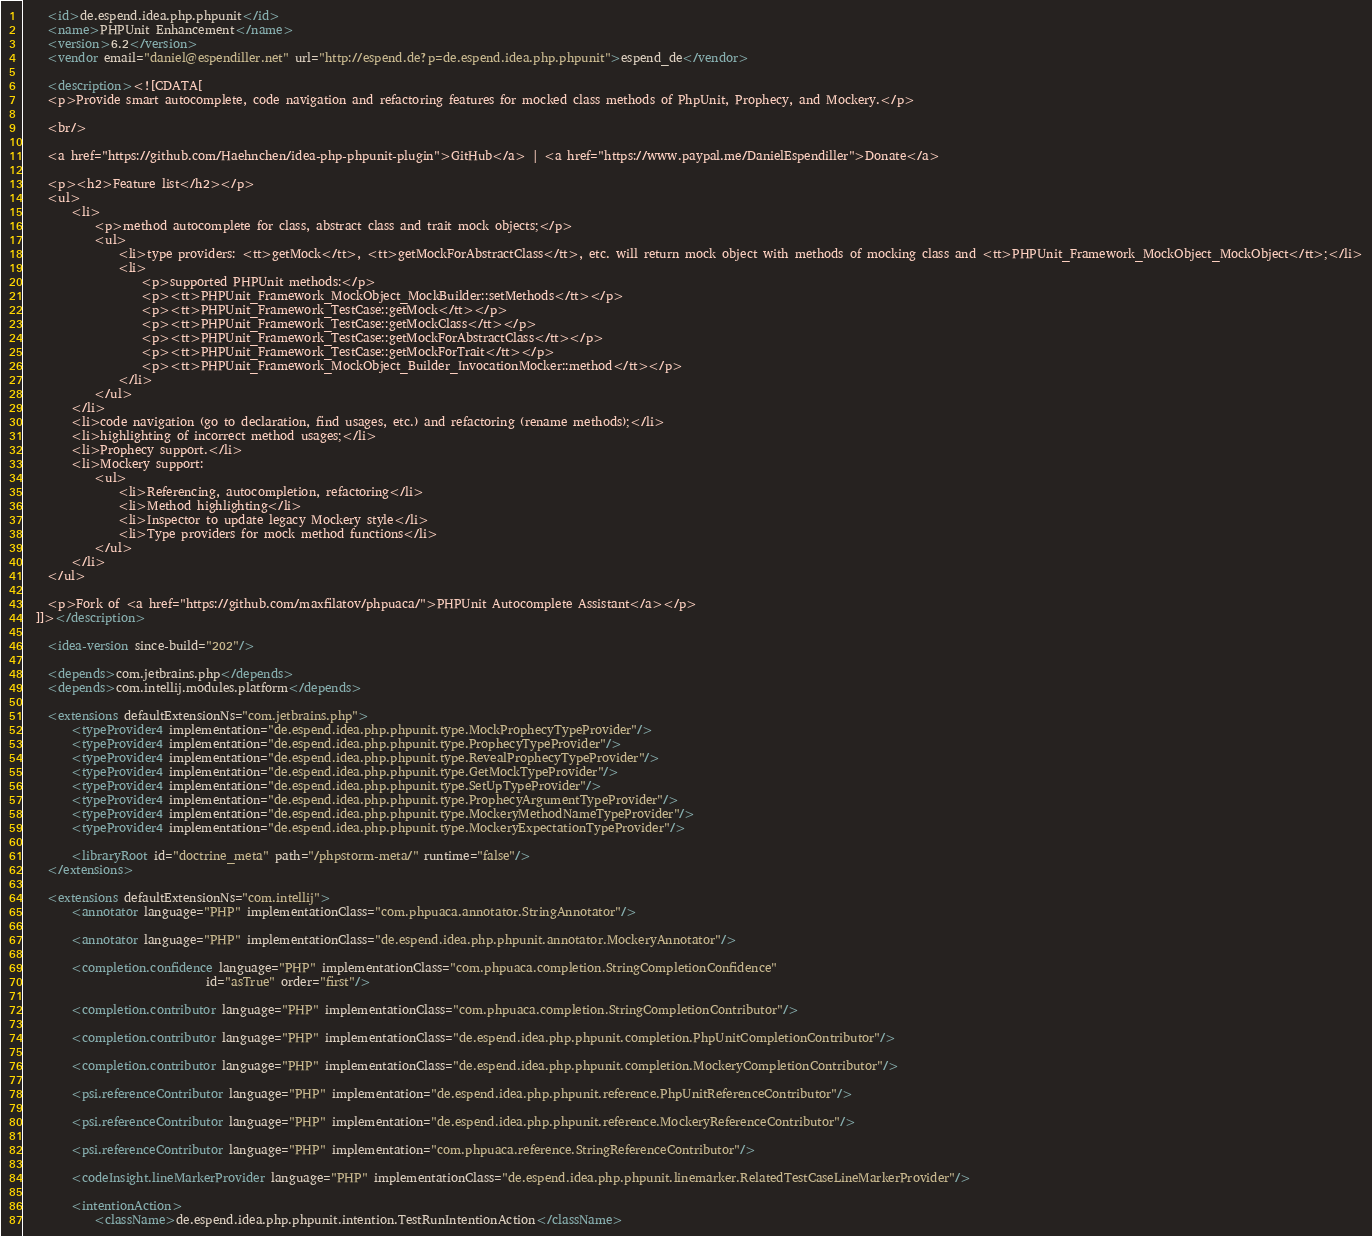<code> <loc_0><loc_0><loc_500><loc_500><_XML_>    <id>de.espend.idea.php.phpunit</id>
    <name>PHPUnit Enhancement</name>
    <version>6.2</version>
    <vendor email="daniel@espendiller.net" url="http://espend.de?p=de.espend.idea.php.phpunit">espend_de</vendor>

    <description><![CDATA[
    <p>Provide smart autocomplete, code navigation and refactoring features for mocked class methods of PhpUnit, Prophecy, and Mockery.</p>

    <br/>

    <a href="https://github.com/Haehnchen/idea-php-phpunit-plugin">GitHub</a> | <a href="https://www.paypal.me/DanielEspendiller">Donate</a>

    <p><h2>Feature list</h2></p>
    <ul>
        <li>
            <p>method autocomplete for class, abstract class and trait mock objects;</p>
            <ul>
                <li>type providers: <tt>getMock</tt>, <tt>getMockForAbstractClass</tt>, etc. will return mock object with methods of mocking class and <tt>PHPUnit_Framework_MockObject_MockObject</tt>;</li>
                <li>
                    <p>supported PHPUnit methods:</p>
                    <p><tt>PHPUnit_Framework_MockObject_MockBuilder::setMethods</tt></p>
                    <p><tt>PHPUnit_Framework_TestCase::getMock</tt></p>
                    <p><tt>PHPUnit_Framework_TestCase::getMockClass</tt></p>
                    <p><tt>PHPUnit_Framework_TestCase::getMockForAbstractClass</tt></p>
                    <p><tt>PHPUnit_Framework_TestCase::getMockForTrait</tt></p>
                    <p><tt>PHPUnit_Framework_MockObject_Builder_InvocationMocker::method</tt></p>
                </li>
            </ul>
        </li>
        <li>code navigation (go to declaration, find usages, etc.) and refactoring (rename methods);</li>
        <li>highlighting of incorrect method usages;</li>
        <li>Prophecy support.</li>
        <li>Mockery support:
            <ul>
                <li>Referencing, autocompletion, refactoring</li>
                <li>Method highlighting</li>
                <li>Inspector to update legacy Mockery style</li>
                <li>Type providers for mock method functions</li>
            </ul>
        </li>
    </ul>

    <p>Fork of <a href="https://github.com/maxfilatov/phpuaca/">PHPUnit Autocomplete Assistant</a></p>
  ]]></description>

    <idea-version since-build="202"/>

    <depends>com.jetbrains.php</depends>
    <depends>com.intellij.modules.platform</depends>

    <extensions defaultExtensionNs="com.jetbrains.php">
        <typeProvider4 implementation="de.espend.idea.php.phpunit.type.MockProphecyTypeProvider"/>
        <typeProvider4 implementation="de.espend.idea.php.phpunit.type.ProphecyTypeProvider"/>
        <typeProvider4 implementation="de.espend.idea.php.phpunit.type.RevealProphecyTypeProvider"/>
        <typeProvider4 implementation="de.espend.idea.php.phpunit.type.GetMockTypeProvider"/>
        <typeProvider4 implementation="de.espend.idea.php.phpunit.type.SetUpTypeProvider"/>
        <typeProvider4 implementation="de.espend.idea.php.phpunit.type.ProphecyArgumentTypeProvider"/>
        <typeProvider4 implementation="de.espend.idea.php.phpunit.type.MockeryMethodNameTypeProvider"/>
        <typeProvider4 implementation="de.espend.idea.php.phpunit.type.MockeryExpectationTypeProvider"/>

        <libraryRoot id="doctrine_meta" path="/phpstorm-meta/" runtime="false"/>
    </extensions>

    <extensions defaultExtensionNs="com.intellij">
        <annotator language="PHP" implementationClass="com.phpuaca.annotator.StringAnnotator"/>

        <annotator language="PHP" implementationClass="de.espend.idea.php.phpunit.annotator.MockeryAnnotator"/>

        <completion.confidence language="PHP" implementationClass="com.phpuaca.completion.StringCompletionConfidence"
                               id="asTrue" order="first"/>

        <completion.contributor language="PHP" implementationClass="com.phpuaca.completion.StringCompletionContributor"/>

        <completion.contributor language="PHP" implementationClass="de.espend.idea.php.phpunit.completion.PhpUnitCompletionContributor"/>

        <completion.contributor language="PHP" implementationClass="de.espend.idea.php.phpunit.completion.MockeryCompletionContributor"/>

        <psi.referenceContributor language="PHP" implementation="de.espend.idea.php.phpunit.reference.PhpUnitReferenceContributor"/>

        <psi.referenceContributor language="PHP" implementation="de.espend.idea.php.phpunit.reference.MockeryReferenceContributor"/>

        <psi.referenceContributor language="PHP" implementation="com.phpuaca.reference.StringReferenceContributor"/>

        <codeInsight.lineMarkerProvider language="PHP" implementationClass="de.espend.idea.php.phpunit.linemarker.RelatedTestCaseLineMarkerProvider"/>

        <intentionAction>
            <className>de.espend.idea.php.phpunit.intention.TestRunIntentionAction</className></code> 